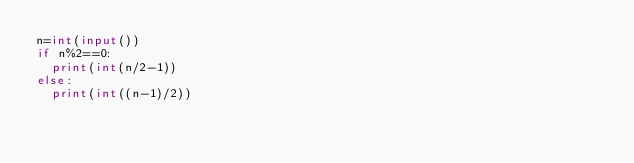Convert code to text. <code><loc_0><loc_0><loc_500><loc_500><_Python_>n=int(input())
if n%2==0:
  print(int(n/2-1))
else:
  print(int((n-1)/2))</code> 